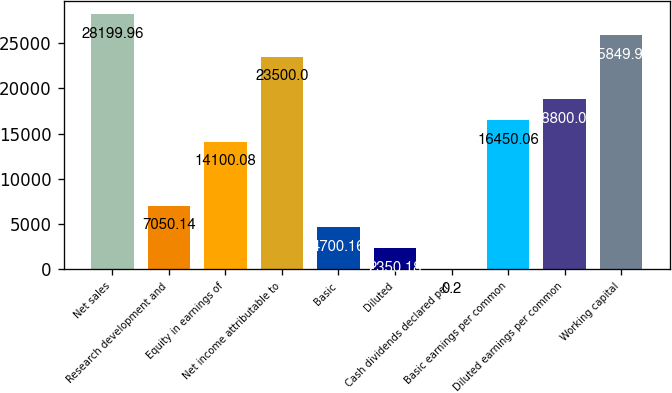Convert chart to OTSL. <chart><loc_0><loc_0><loc_500><loc_500><bar_chart><fcel>Net sales<fcel>Research development and<fcel>Equity in earnings of<fcel>Net income attributable to<fcel>Basic<fcel>Diluted<fcel>Cash dividends declared per<fcel>Basic earnings per common<fcel>Diluted earnings per common<fcel>Working capital<nl><fcel>28200<fcel>7050.14<fcel>14100.1<fcel>23500<fcel>4700.16<fcel>2350.18<fcel>0.2<fcel>16450.1<fcel>18800<fcel>25850<nl></chart> 